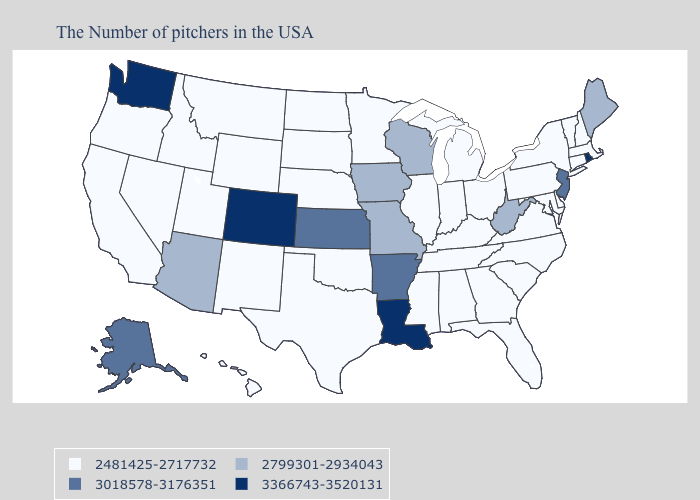Name the states that have a value in the range 3366743-3520131?
Be succinct. Rhode Island, Louisiana, Colorado, Washington. Name the states that have a value in the range 2481425-2717732?
Quick response, please. Massachusetts, New Hampshire, Vermont, Connecticut, New York, Delaware, Maryland, Pennsylvania, Virginia, North Carolina, South Carolina, Ohio, Florida, Georgia, Michigan, Kentucky, Indiana, Alabama, Tennessee, Illinois, Mississippi, Minnesota, Nebraska, Oklahoma, Texas, South Dakota, North Dakota, Wyoming, New Mexico, Utah, Montana, Idaho, Nevada, California, Oregon, Hawaii. Among the states that border Minnesota , which have the highest value?
Be succinct. Wisconsin, Iowa. Does Kansas have a higher value than Maryland?
Keep it brief. Yes. Does Washington have the highest value in the USA?
Write a very short answer. Yes. What is the highest value in states that border South Carolina?
Keep it brief. 2481425-2717732. What is the lowest value in the USA?
Give a very brief answer. 2481425-2717732. Does Ohio have the lowest value in the USA?
Answer briefly. Yes. Which states have the lowest value in the USA?
Short answer required. Massachusetts, New Hampshire, Vermont, Connecticut, New York, Delaware, Maryland, Pennsylvania, Virginia, North Carolina, South Carolina, Ohio, Florida, Georgia, Michigan, Kentucky, Indiana, Alabama, Tennessee, Illinois, Mississippi, Minnesota, Nebraska, Oklahoma, Texas, South Dakota, North Dakota, Wyoming, New Mexico, Utah, Montana, Idaho, Nevada, California, Oregon, Hawaii. Does the map have missing data?
Give a very brief answer. No. What is the value of Louisiana?
Quick response, please. 3366743-3520131. How many symbols are there in the legend?
Give a very brief answer. 4. What is the value of Pennsylvania?
Give a very brief answer. 2481425-2717732. What is the highest value in the South ?
Quick response, please. 3366743-3520131. Among the states that border Louisiana , which have the lowest value?
Short answer required. Mississippi, Texas. 